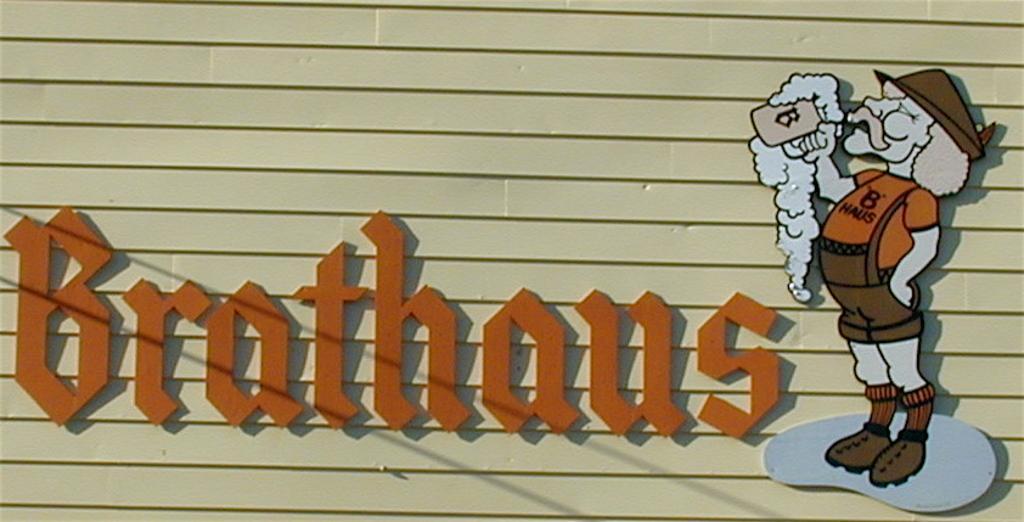How would you summarize this image in a sentence or two? In this picture we can see a wall, there is a picture of a person on the right side, we can see some text in the middle. 